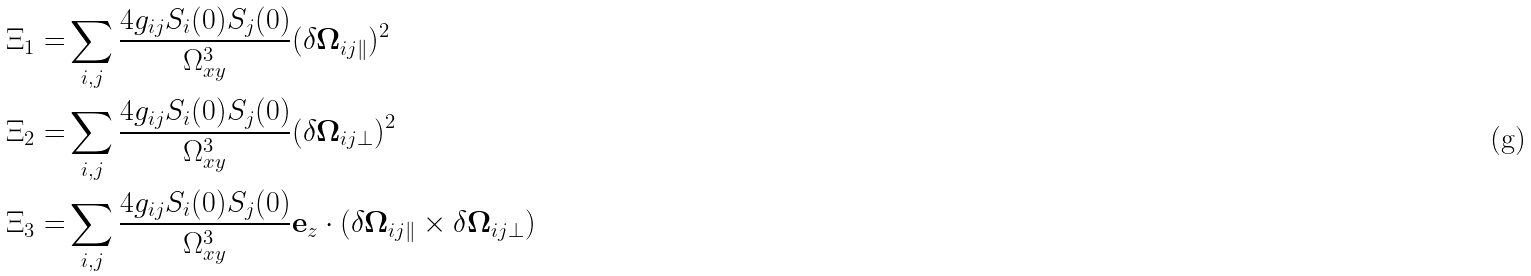<formula> <loc_0><loc_0><loc_500><loc_500>\Xi _ { 1 } = & \sum _ { i , j } \frac { 4 g _ { i j } S _ { i } ( 0 ) S _ { j } ( 0 ) } { \Omega _ { x y } ^ { 3 } } ( \delta \mathbf \Omega _ { i j \| } ) ^ { 2 } \\ \Xi _ { 2 } = & \sum _ { i , j } \frac { 4 g _ { i j } S _ { i } ( 0 ) S _ { j } ( 0 ) } { \Omega _ { x y } ^ { 3 } } ( \delta \mathbf \Omega _ { i j \perp } ) ^ { 2 } \\ \Xi _ { 3 } = & \sum _ { i , j } \frac { 4 g _ { i j } S _ { i } ( 0 ) S _ { j } ( 0 ) } { \Omega _ { x y } ^ { 3 } } \mathbf e _ { z } \cdot ( \delta \mathbf \Omega _ { i j \| } \times \delta \mathbf \Omega _ { i j \perp } )</formula> 